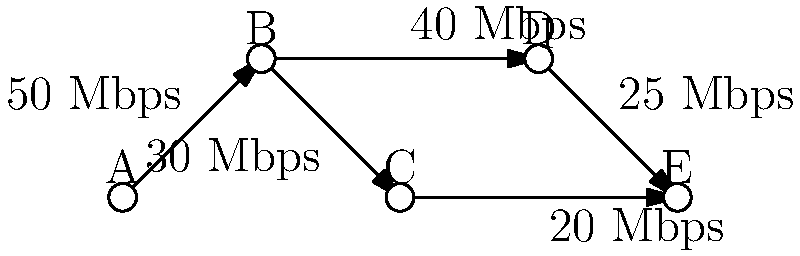In the network diagram above, each node represents a device, and the arrows represent data flow directions with their respective bandwidth capacities. If device A is sending data to device E at a rate of 15 Mbps, what percentage of the total available bandwidth between A and E is being utilized? To solve this problem, we need to follow these steps:

1. Identify possible paths from A to E:
   Path 1: A → B → C → E
   Path 2: A → B → D → E

2. Calculate the maximum bandwidth for each path:
   Path 1: min(50, 30, 20) = 20 Mbps
   Path 2: min(50, 40, 25) = 25 Mbps

3. The total available bandwidth is the sum of the maximum bandwidths of all paths:
   Total available bandwidth = 20 + 25 = 45 Mbps

4. Calculate the percentage of bandwidth utilization:
   Utilization = (Data rate / Total available bandwidth) × 100%
   Utilization = (15 Mbps / 45 Mbps) × 100%
   Utilization = 0.3333... × 100% ≈ 33.33%

Therefore, the bandwidth utilization from A to E is approximately 33.33%.
Answer: 33.33% 